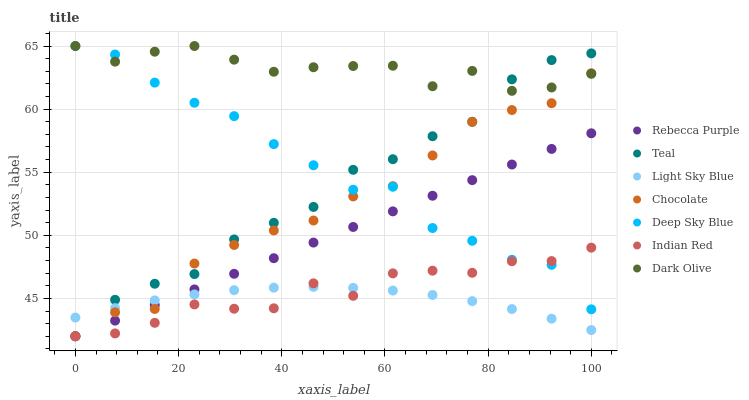Does Light Sky Blue have the minimum area under the curve?
Answer yes or no. Yes. Does Dark Olive have the maximum area under the curve?
Answer yes or no. Yes. Does Deep Sky Blue have the minimum area under the curve?
Answer yes or no. No. Does Deep Sky Blue have the maximum area under the curve?
Answer yes or no. No. Is Rebecca Purple the smoothest?
Answer yes or no. Yes. Is Deep Sky Blue the roughest?
Answer yes or no. Yes. Is Dark Olive the smoothest?
Answer yes or no. No. Is Dark Olive the roughest?
Answer yes or no. No. Does Teal have the lowest value?
Answer yes or no. Yes. Does Deep Sky Blue have the lowest value?
Answer yes or no. No. Does Dark Olive have the highest value?
Answer yes or no. Yes. Does Chocolate have the highest value?
Answer yes or no. No. Is Light Sky Blue less than Dark Olive?
Answer yes or no. Yes. Is Dark Olive greater than Rebecca Purple?
Answer yes or no. Yes. Does Dark Olive intersect Chocolate?
Answer yes or no. Yes. Is Dark Olive less than Chocolate?
Answer yes or no. No. Is Dark Olive greater than Chocolate?
Answer yes or no. No. Does Light Sky Blue intersect Dark Olive?
Answer yes or no. No. 